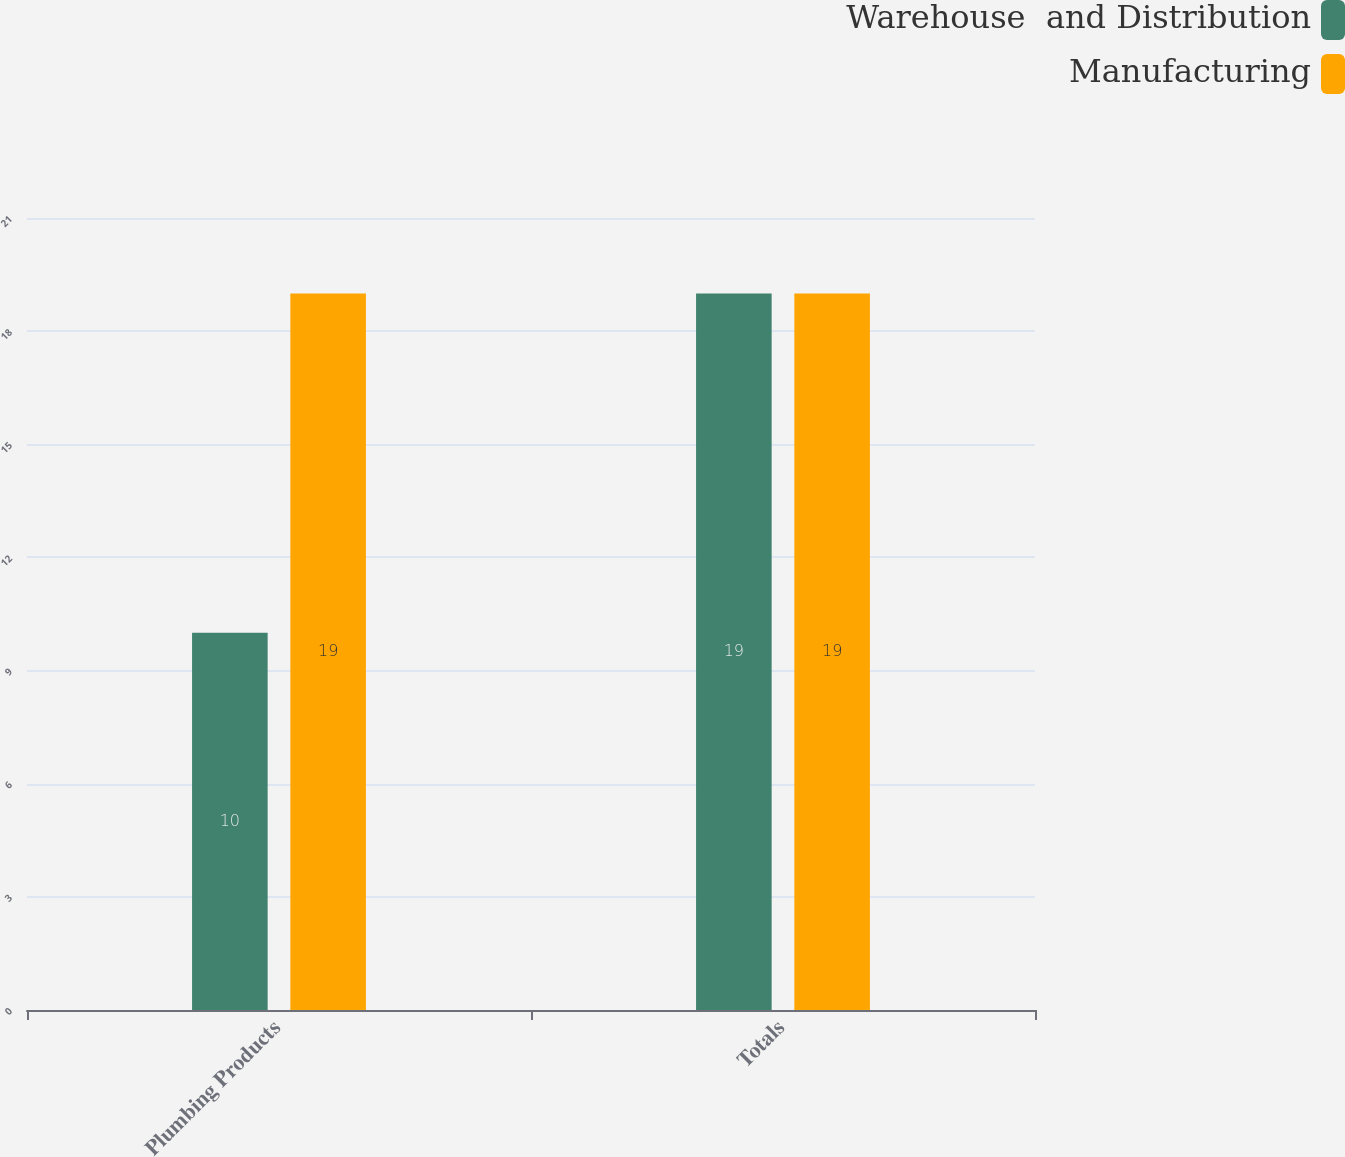Convert chart to OTSL. <chart><loc_0><loc_0><loc_500><loc_500><stacked_bar_chart><ecel><fcel>Plumbing Products<fcel>Totals<nl><fcel>Warehouse  and Distribution<fcel>10<fcel>19<nl><fcel>Manufacturing<fcel>19<fcel>19<nl></chart> 